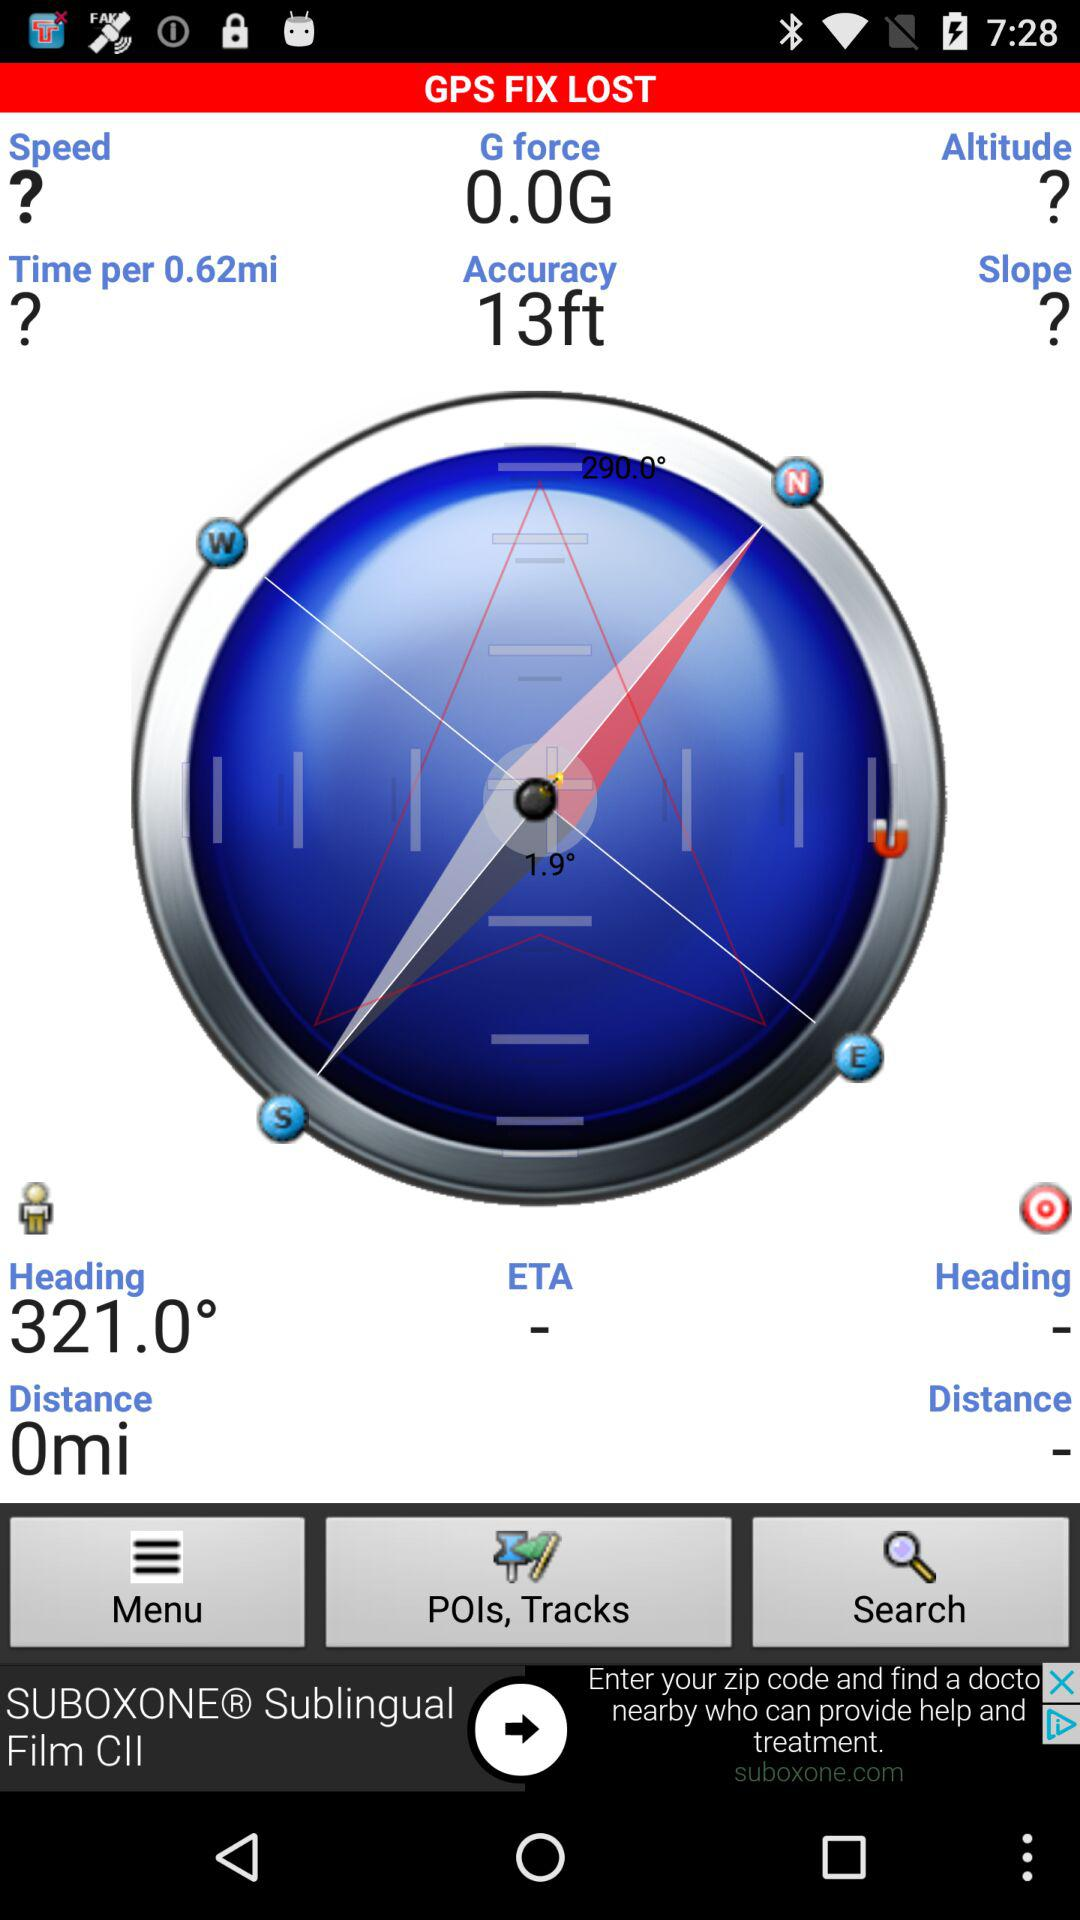When was the application copyrighted?
When the provided information is insufficient, respond with <no answer>. <no answer> 